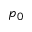<formula> <loc_0><loc_0><loc_500><loc_500>p _ { 0 }</formula> 